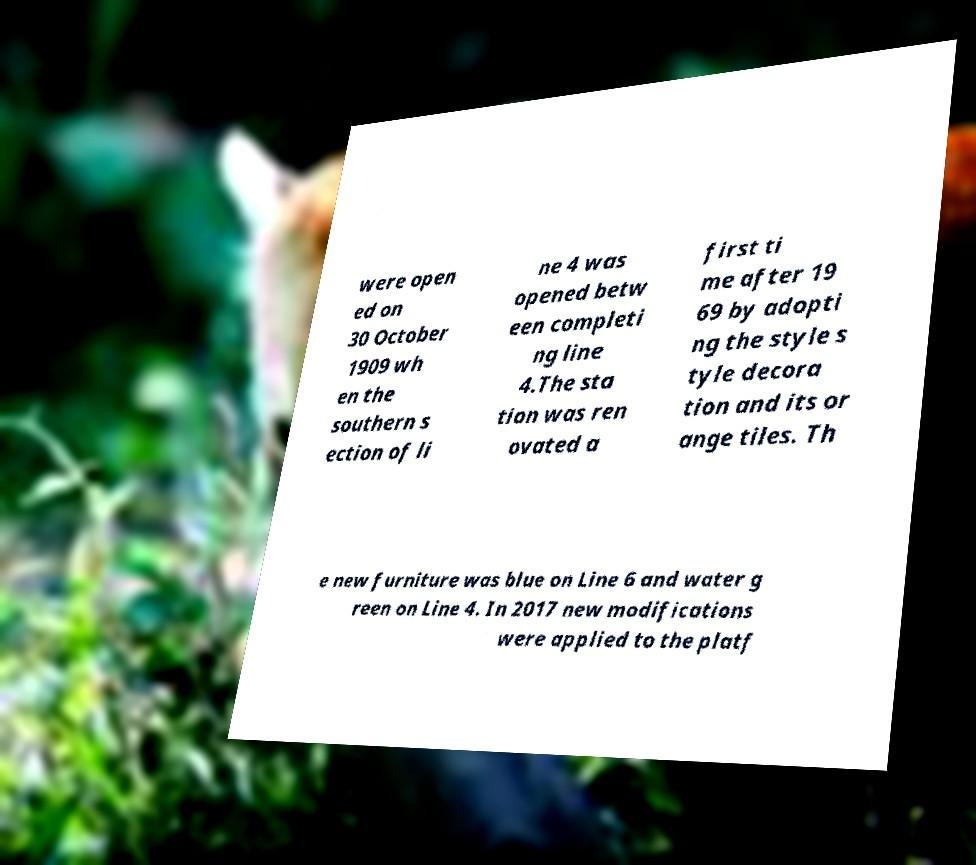Could you extract and type out the text from this image? were open ed on 30 October 1909 wh en the southern s ection of li ne 4 was opened betw een completi ng line 4.The sta tion was ren ovated a first ti me after 19 69 by adopti ng the style s tyle decora tion and its or ange tiles. Th e new furniture was blue on Line 6 and water g reen on Line 4. In 2017 new modifications were applied to the platf 